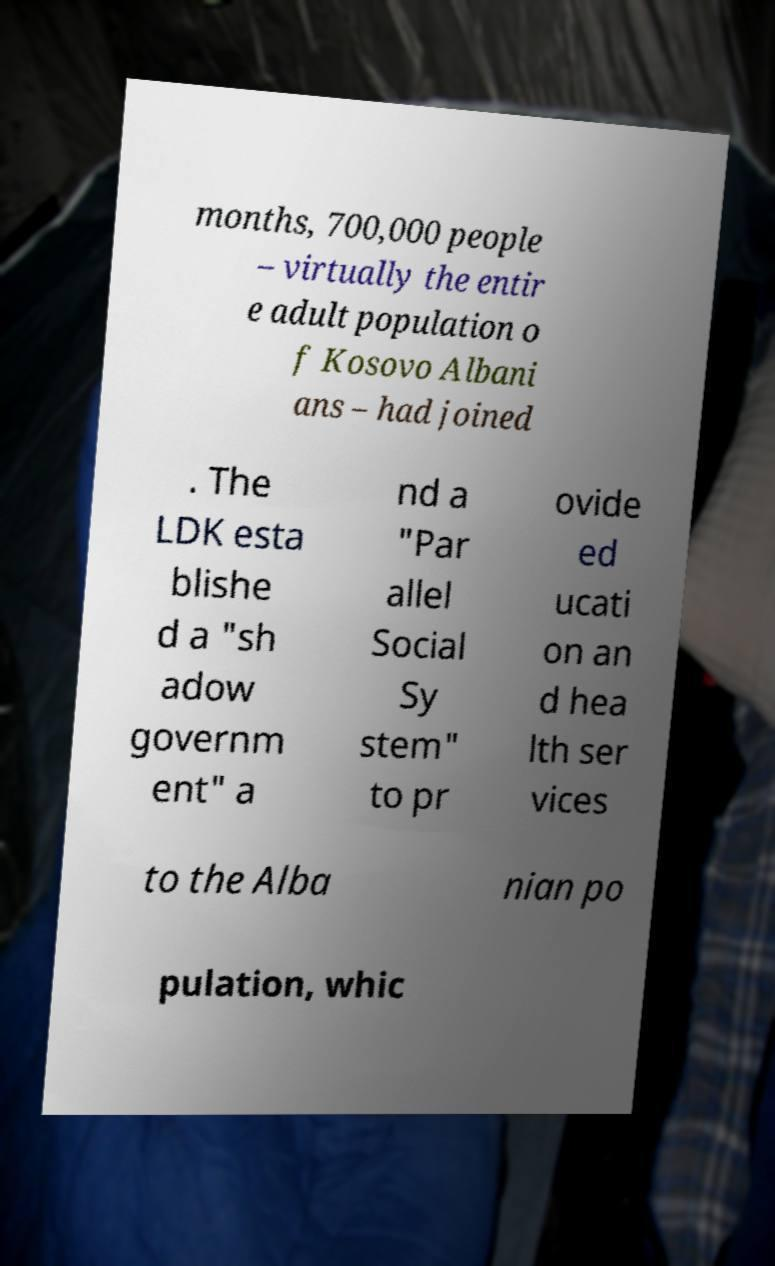What messages or text are displayed in this image? I need them in a readable, typed format. months, 700,000 people – virtually the entir e adult population o f Kosovo Albani ans – had joined . The LDK esta blishe d a "sh adow governm ent" a nd a "Par allel Social Sy stem" to pr ovide ed ucati on an d hea lth ser vices to the Alba nian po pulation, whic 